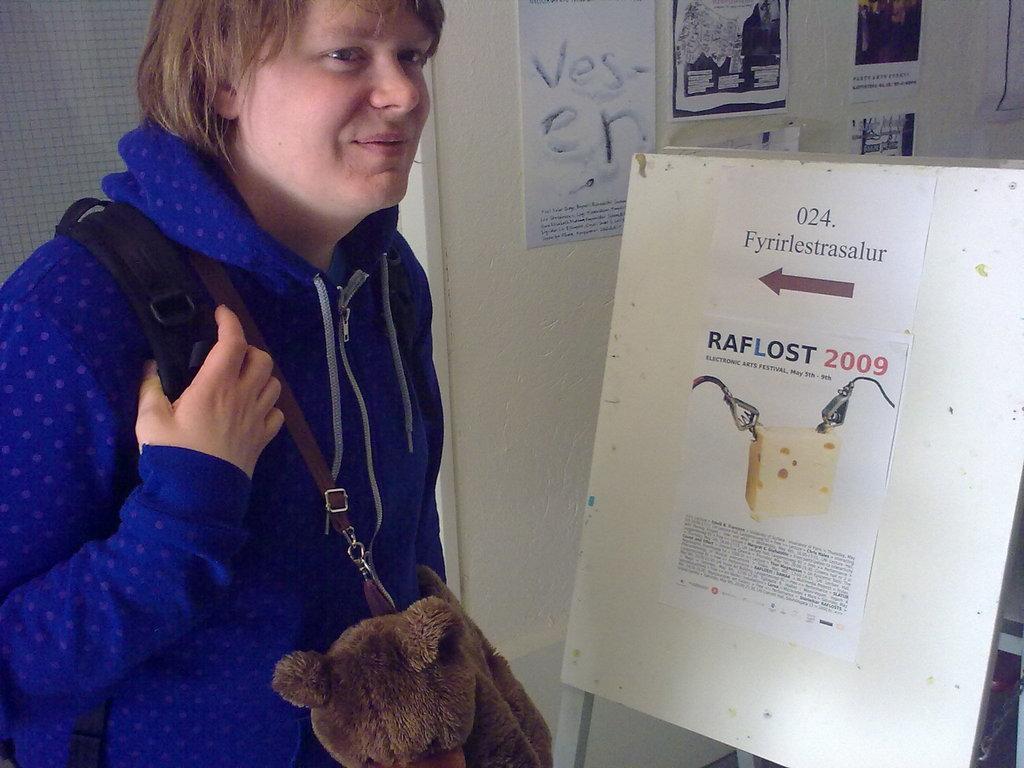Describe this image in one or two sentences. On the left side of the image there is a man with a bag. Beside him on the right side there is a board. On the board there are papers with images and text. Behind the board there is a wall with posters. 